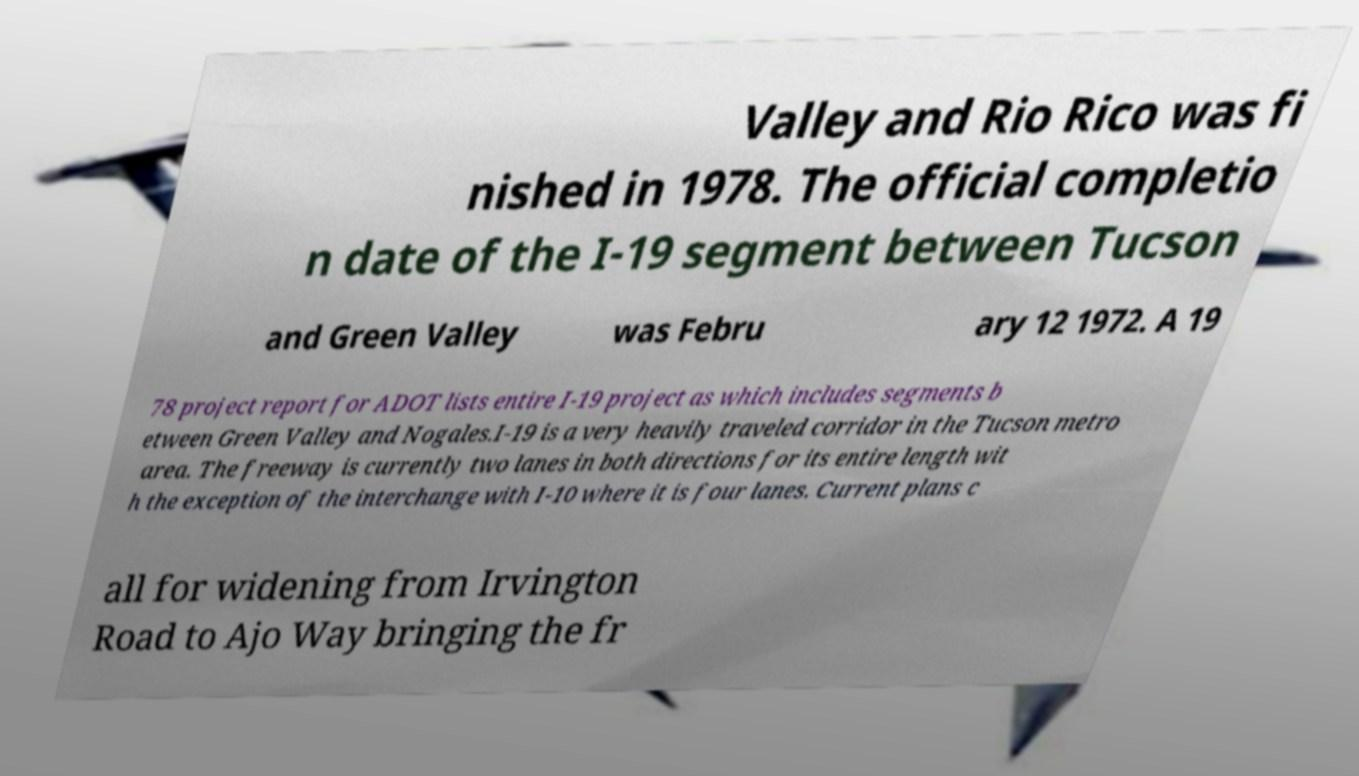Can you read and provide the text displayed in the image?This photo seems to have some interesting text. Can you extract and type it out for me? Valley and Rio Rico was fi nished in 1978. The official completio n date of the I-19 segment between Tucson and Green Valley was Febru ary 12 1972. A 19 78 project report for ADOT lists entire I-19 project as which includes segments b etween Green Valley and Nogales.I-19 is a very heavily traveled corridor in the Tucson metro area. The freeway is currently two lanes in both directions for its entire length wit h the exception of the interchange with I-10 where it is four lanes. Current plans c all for widening from Irvington Road to Ajo Way bringing the fr 